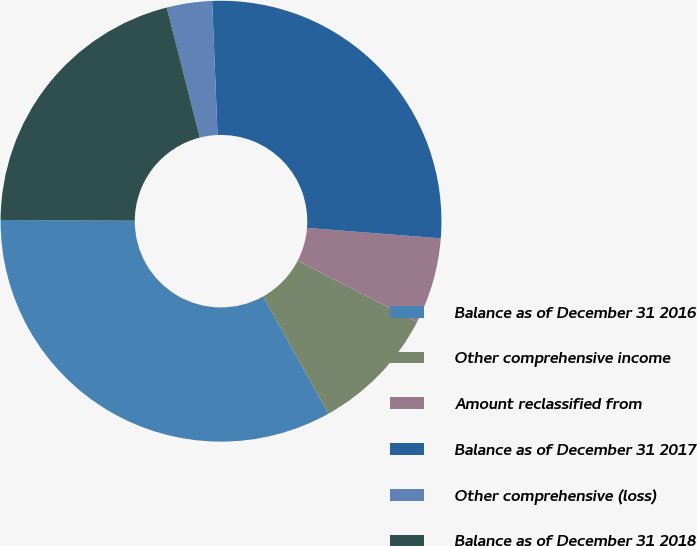<chart> <loc_0><loc_0><loc_500><loc_500><pie_chart><fcel>Balance as of December 31 2016<fcel>Other comprehensive income<fcel>Amount reclassified from<fcel>Balance as of December 31 2017<fcel>Other comprehensive (loss)<fcel>Balance as of December 31 2018<nl><fcel>33.2%<fcel>9.33%<fcel>6.32%<fcel>26.88%<fcel>3.32%<fcel>20.95%<nl></chart> 